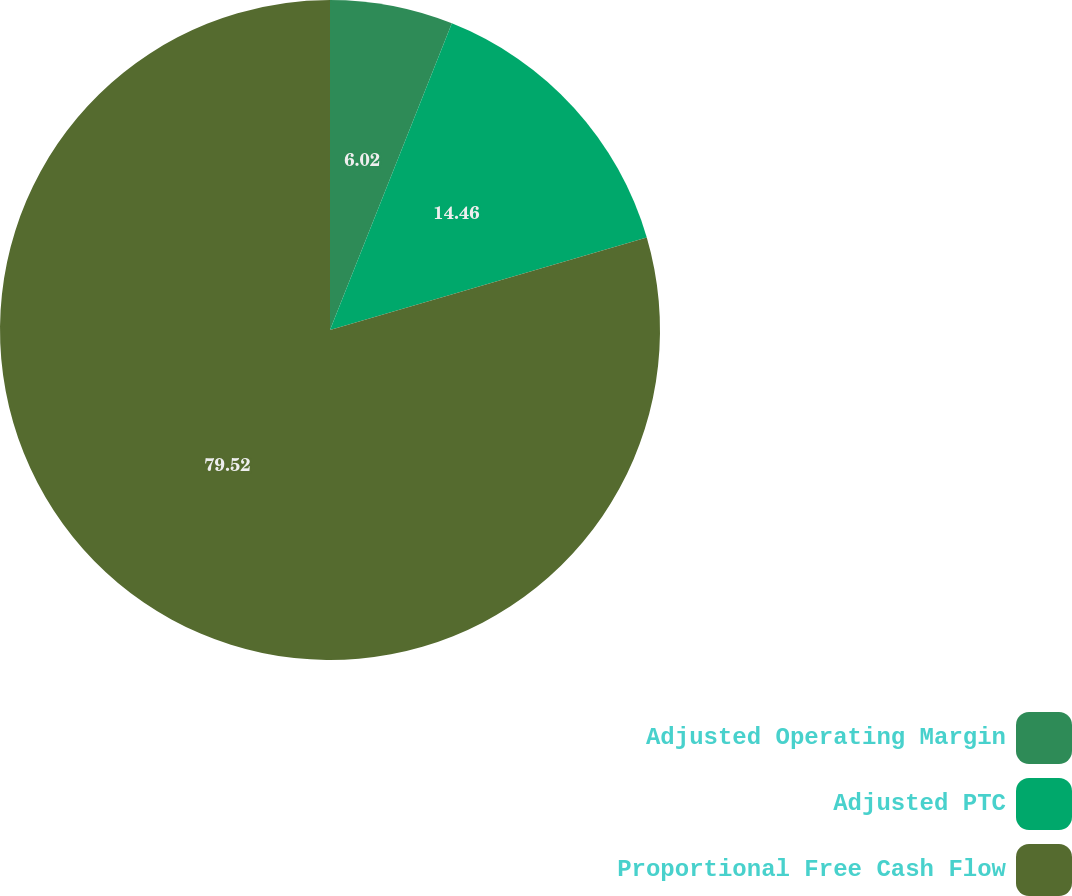Convert chart to OTSL. <chart><loc_0><loc_0><loc_500><loc_500><pie_chart><fcel>Adjusted Operating Margin<fcel>Adjusted PTC<fcel>Proportional Free Cash Flow<nl><fcel>6.02%<fcel>14.46%<fcel>79.52%<nl></chart> 